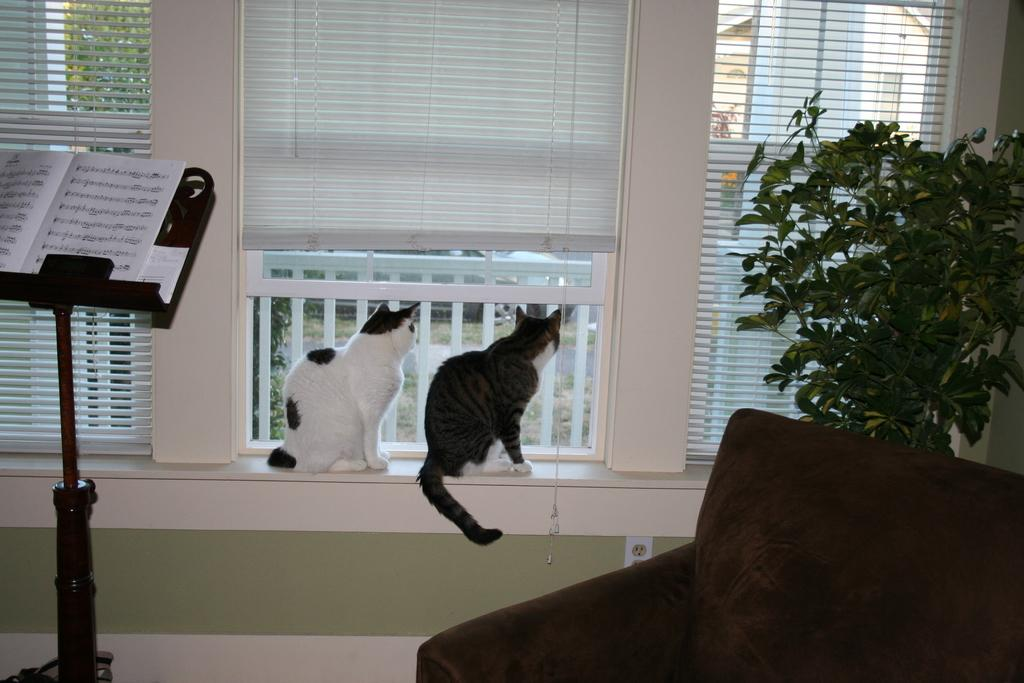How many cats are present in the image? There are two cats sitting in the image. What type of vegetation can be seen in the image? There is a green color plant on the right side of the image. What type of furniture is visible in the image? There is a sofa in the image. What allows natural light to enter the room in the image? There are windows visible in the image. What type of structure is the can holding in the image? There is no can present in the image, so it is not possible to determine the type of structure holding it. 